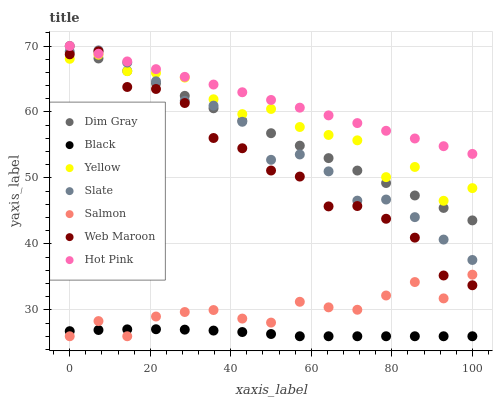Does Black have the minimum area under the curve?
Answer yes or no. Yes. Does Hot Pink have the maximum area under the curve?
Answer yes or no. Yes. Does Salmon have the minimum area under the curve?
Answer yes or no. No. Does Salmon have the maximum area under the curve?
Answer yes or no. No. Is Hot Pink the smoothest?
Answer yes or no. Yes. Is Yellow the roughest?
Answer yes or no. Yes. Is Salmon the smoothest?
Answer yes or no. No. Is Salmon the roughest?
Answer yes or no. No. Does Salmon have the lowest value?
Answer yes or no. Yes. Does Slate have the lowest value?
Answer yes or no. No. Does Hot Pink have the highest value?
Answer yes or no. Yes. Does Salmon have the highest value?
Answer yes or no. No. Is Black less than Hot Pink?
Answer yes or no. Yes. Is Hot Pink greater than Yellow?
Answer yes or no. Yes. Does Slate intersect Hot Pink?
Answer yes or no. Yes. Is Slate less than Hot Pink?
Answer yes or no. No. Is Slate greater than Hot Pink?
Answer yes or no. No. Does Black intersect Hot Pink?
Answer yes or no. No. 